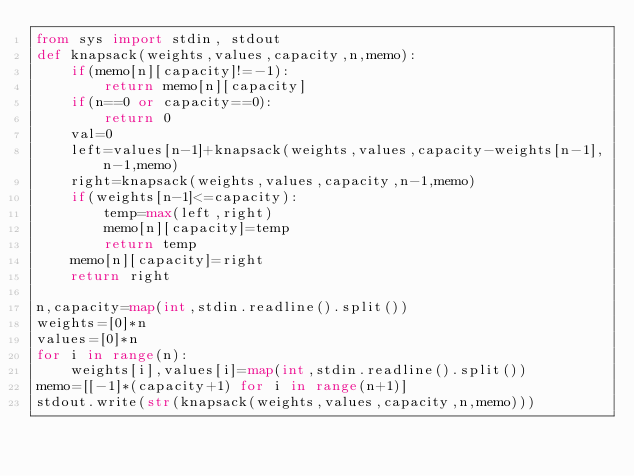<code> <loc_0><loc_0><loc_500><loc_500><_Python_>from sys import stdin, stdout
def knapsack(weights,values,capacity,n,memo):
    if(memo[n][capacity]!=-1):
        return memo[n][capacity]
    if(n==0 or capacity==0):
        return 0
    val=0
    left=values[n-1]+knapsack(weights,values,capacity-weights[n-1],n-1,memo)
    right=knapsack(weights,values,capacity,n-1,memo)
    if(weights[n-1]<=capacity):
        temp=max(left,right)
        memo[n][capacity]=temp
        return temp
    memo[n][capacity]=right
    return right

n,capacity=map(int,stdin.readline().split())
weights=[0]*n
values=[0]*n
for i in range(n):
    weights[i],values[i]=map(int,stdin.readline().split())
memo=[[-1]*(capacity+1) for i in range(n+1)]
stdout.write(str(knapsack(weights,values,capacity,n,memo)))</code> 